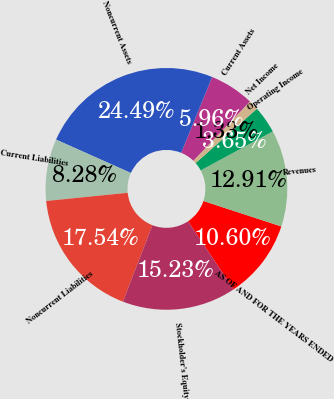Convert chart to OTSL. <chart><loc_0><loc_0><loc_500><loc_500><pie_chart><fcel>AS OF AND FOR THE YEARS ENDED<fcel>Revenues<fcel>Operating Income<fcel>Net Income<fcel>Current Assets<fcel>Noncurrent Assets<fcel>Current Liabilities<fcel>Noncurrent Liabilities<fcel>Stockholder's Equity<nl><fcel>10.6%<fcel>12.91%<fcel>3.65%<fcel>1.33%<fcel>5.96%<fcel>24.49%<fcel>8.28%<fcel>17.54%<fcel>15.23%<nl></chart> 